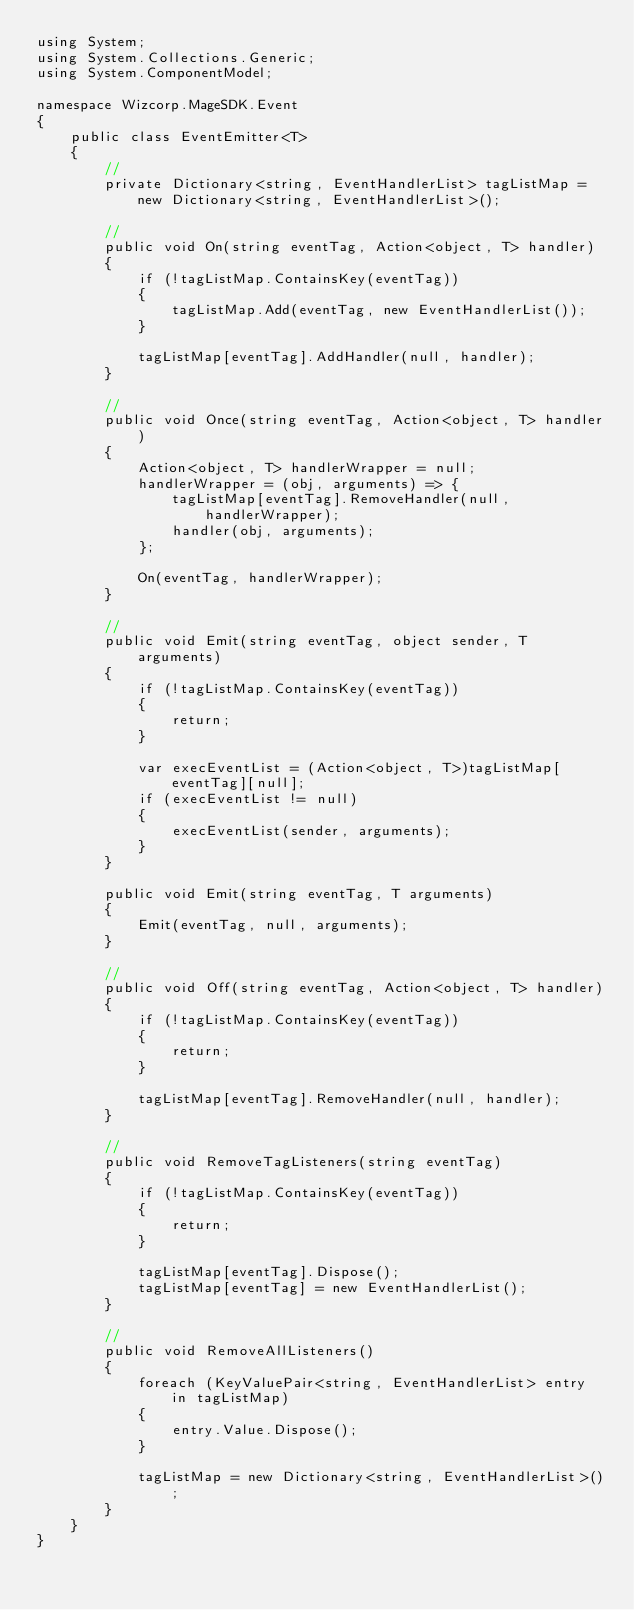Convert code to text. <code><loc_0><loc_0><loc_500><loc_500><_C#_>using System;
using System.Collections.Generic;
using System.ComponentModel;

namespace Wizcorp.MageSDK.Event
{
	public class EventEmitter<T>
	{
		//
		private Dictionary<string, EventHandlerList> tagListMap = new Dictionary<string, EventHandlerList>();

		//
		public void On(string eventTag, Action<object, T> handler)
		{
			if (!tagListMap.ContainsKey(eventTag))
			{
				tagListMap.Add(eventTag, new EventHandlerList());
			}

			tagListMap[eventTag].AddHandler(null, handler);
		}

		//
		public void Once(string eventTag, Action<object, T> handler)
		{
			Action<object, T> handlerWrapper = null;
			handlerWrapper = (obj, arguments) => {
				tagListMap[eventTag].RemoveHandler(null, handlerWrapper);
				handler(obj, arguments);
			};

			On(eventTag, handlerWrapper);
		}

		//
		public void Emit(string eventTag, object sender, T arguments)
		{
			if (!tagListMap.ContainsKey(eventTag))
			{
				return;
			}

			var execEventList = (Action<object, T>)tagListMap[eventTag][null];
			if (execEventList != null)
			{
				execEventList(sender, arguments);
			}
		}

		public void Emit(string eventTag, T arguments)
		{
			Emit(eventTag, null, arguments);
		}

		//
		public void Off(string eventTag, Action<object, T> handler)
		{
			if (!tagListMap.ContainsKey(eventTag))
			{
				return;
			}

			tagListMap[eventTag].RemoveHandler(null, handler);
		}

		//
		public void RemoveTagListeners(string eventTag)
		{
			if (!tagListMap.ContainsKey(eventTag))
			{
				return;
			}

			tagListMap[eventTag].Dispose();
			tagListMap[eventTag] = new EventHandlerList();
		}

		//
		public void RemoveAllListeners()
		{
			foreach (KeyValuePair<string, EventHandlerList> entry in tagListMap)
			{
				entry.Value.Dispose();
			}

			tagListMap = new Dictionary<string, EventHandlerList>();
		}
	}
}
</code> 